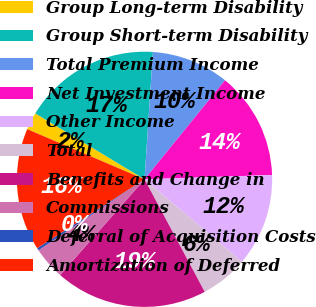Convert chart. <chart><loc_0><loc_0><loc_500><loc_500><pie_chart><fcel>Group Long-term Disability<fcel>Group Short-term Disability<fcel>Total Premium Income<fcel>Net Investment Income<fcel>Other Income<fcel>Total<fcel>Benefits and Change in<fcel>Commissions<fcel>Deferral of Acquisition Costs<fcel>Amortization of Deferred<nl><fcel>2.21%<fcel>17.41%<fcel>9.81%<fcel>13.61%<fcel>11.71%<fcel>6.01%<fcel>19.32%<fcel>4.11%<fcel>0.3%<fcel>15.51%<nl></chart> 